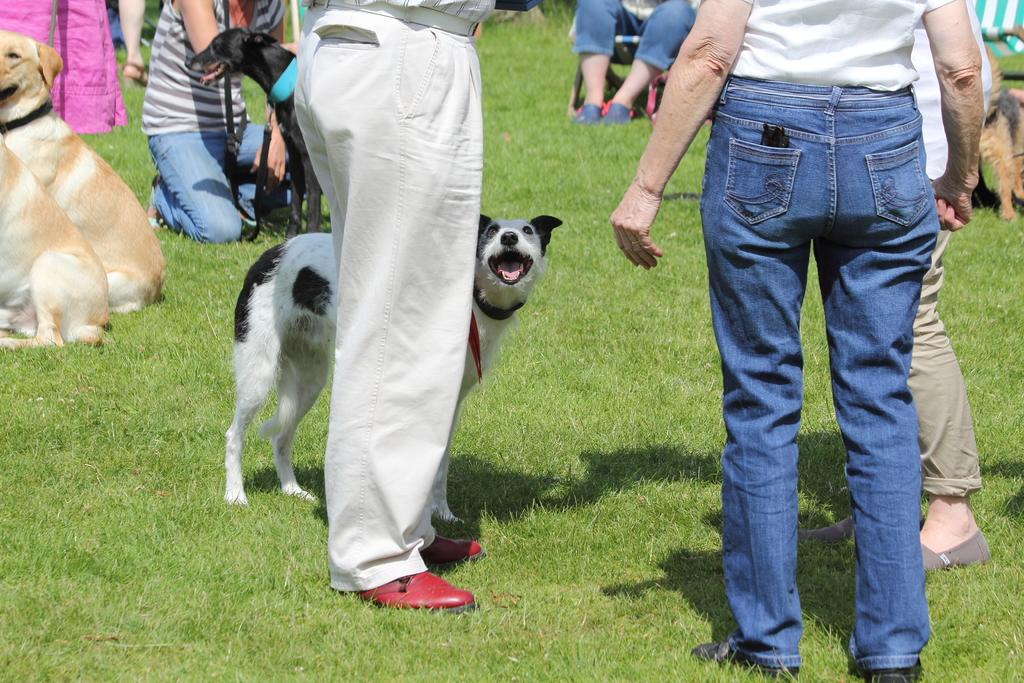What are the people in the image doing? There are people standing, sitting on a chair, and in a squat position in the image. Can you describe the position of the person sitting in the image? The person sitting is on a chair in the image. What is the location of the dogs in the image? The dogs are on the grass path in the image. What type of feather is being used by the person in the squat position? There is no feather present in the image, and therefore no such activity can be observed. 